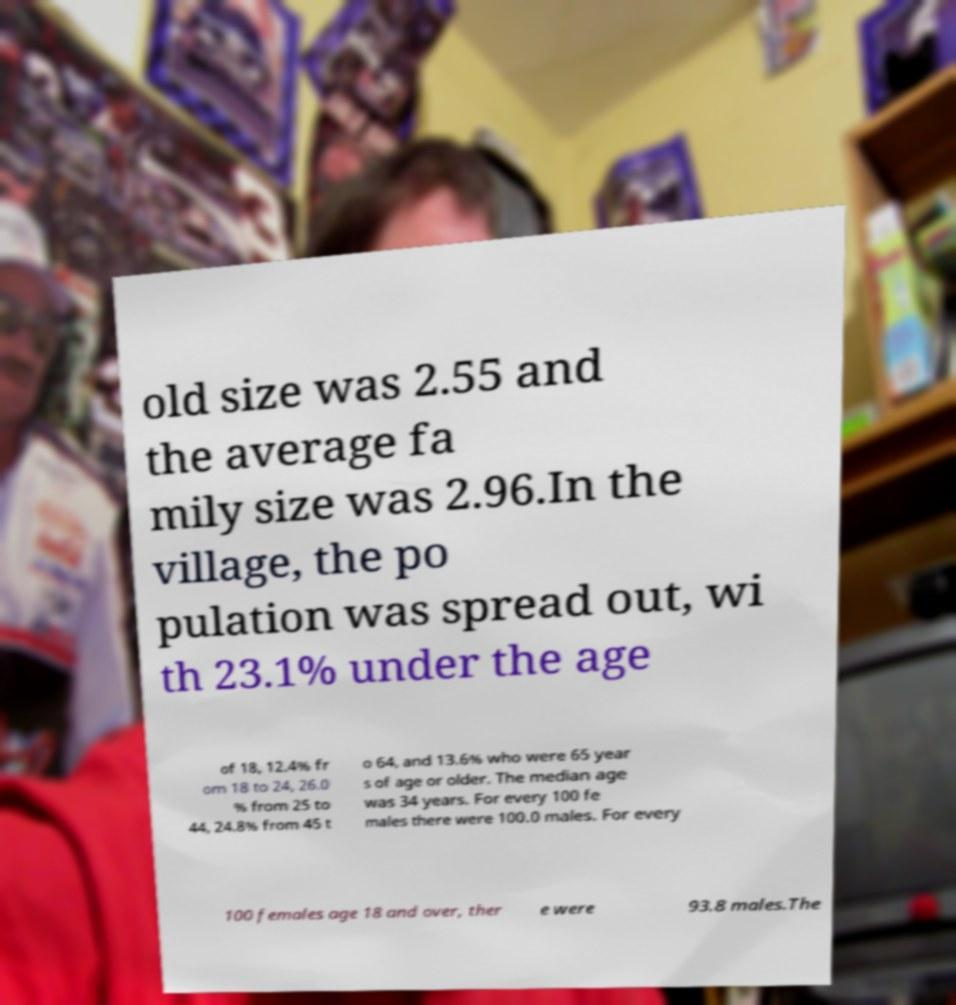What messages or text are displayed in this image? I need them in a readable, typed format. old size was 2.55 and the average fa mily size was 2.96.In the village, the po pulation was spread out, wi th 23.1% under the age of 18, 12.4% fr om 18 to 24, 26.0 % from 25 to 44, 24.8% from 45 t o 64, and 13.6% who were 65 year s of age or older. The median age was 34 years. For every 100 fe males there were 100.0 males. For every 100 females age 18 and over, ther e were 93.8 males.The 